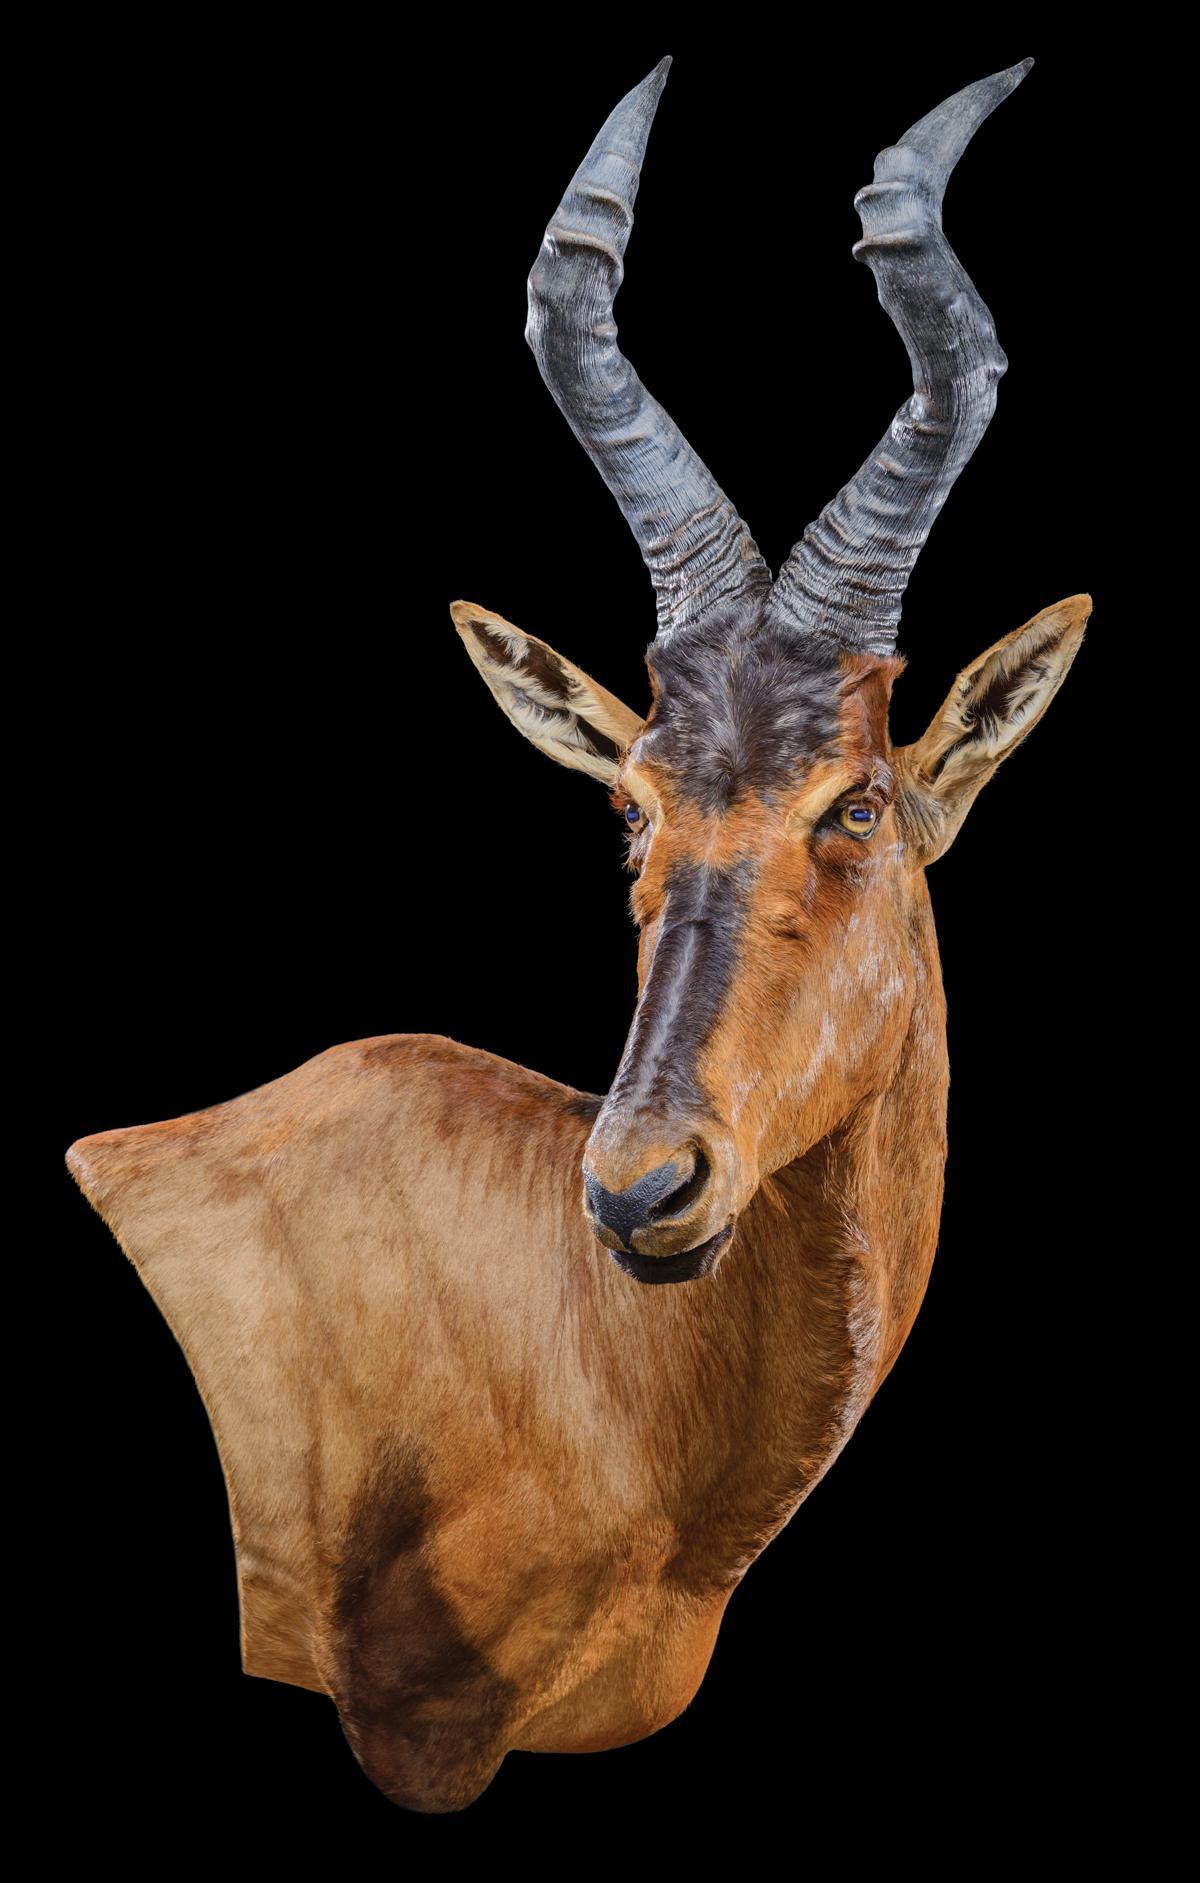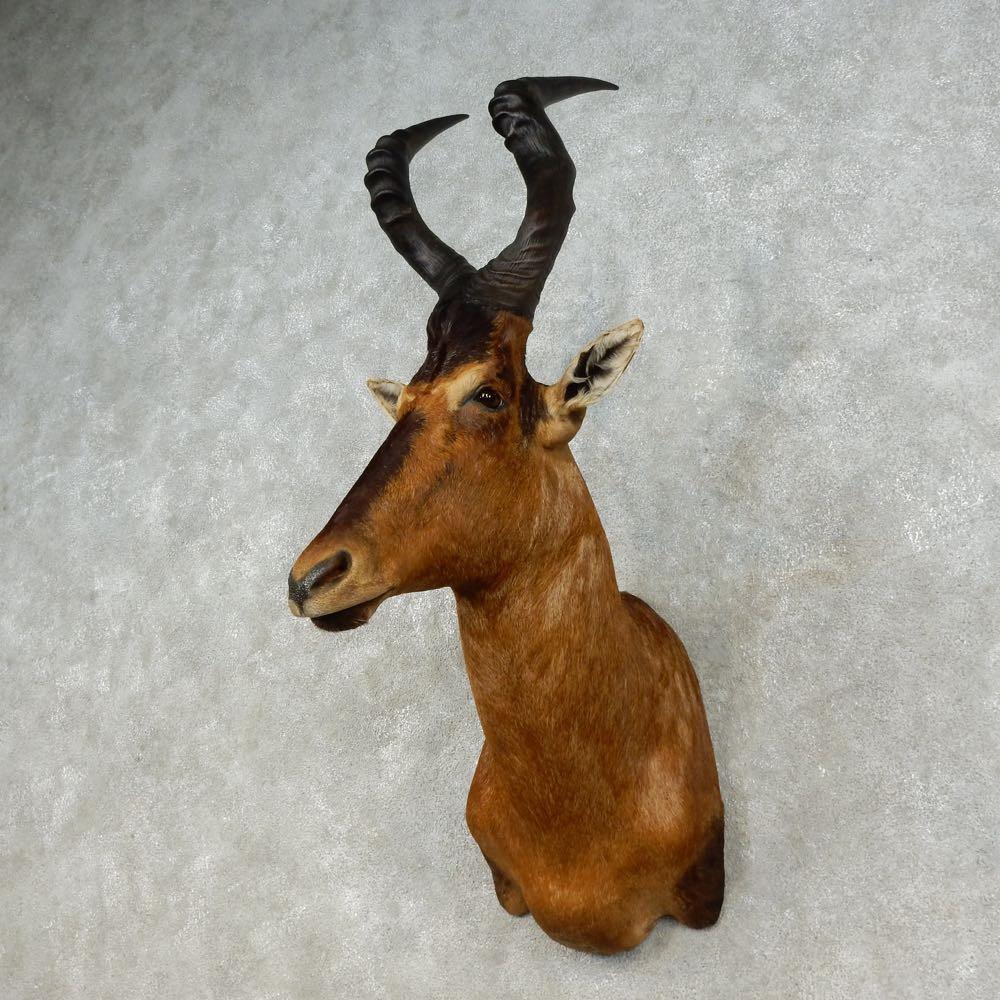The first image is the image on the left, the second image is the image on the right. For the images displayed, is the sentence "At least one of the animals is mounted on a grey marblized wall." factually correct? Answer yes or no. Yes. 